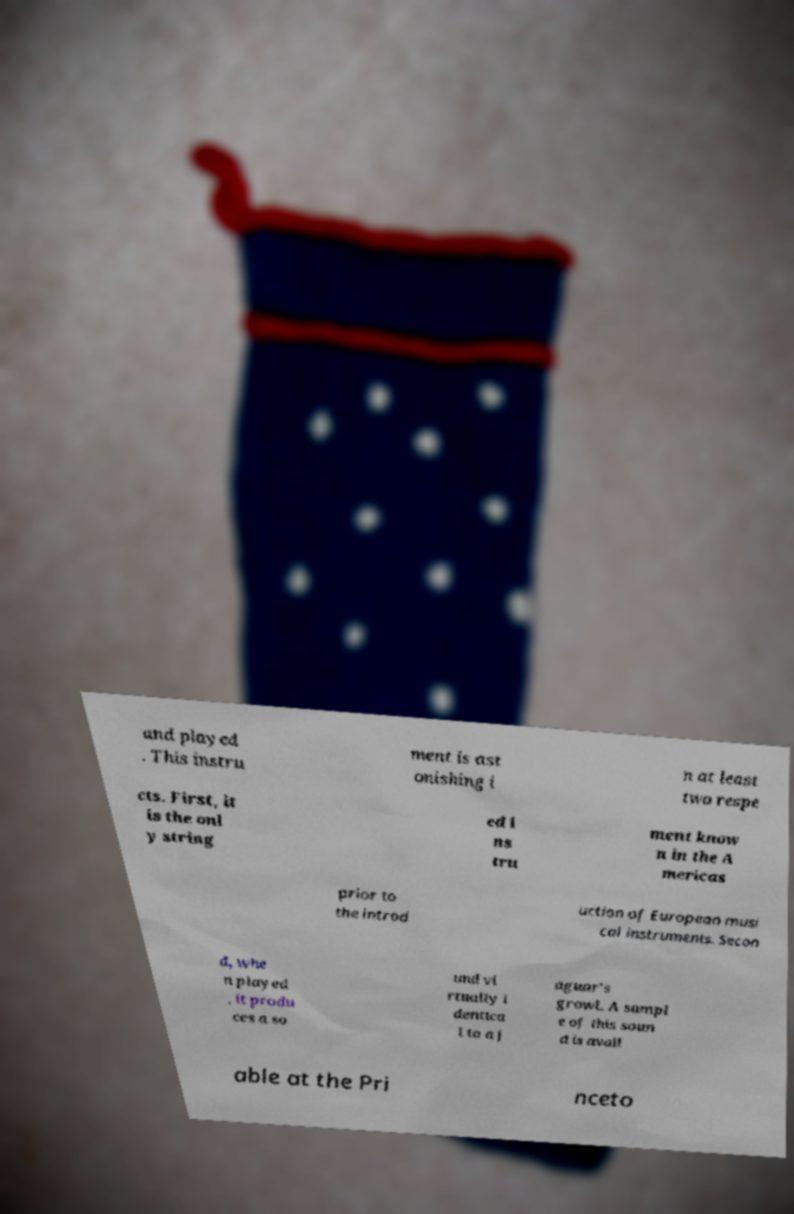Could you assist in decoding the text presented in this image and type it out clearly? and played . This instru ment is ast onishing i n at least two respe cts. First, it is the onl y string ed i ns tru ment know n in the A mericas prior to the introd uction of European musi cal instruments. Secon d, whe n played , it produ ces a so und vi rtually i dentica l to a j aguar's growl. A sampl e of this soun d is avail able at the Pri nceto 